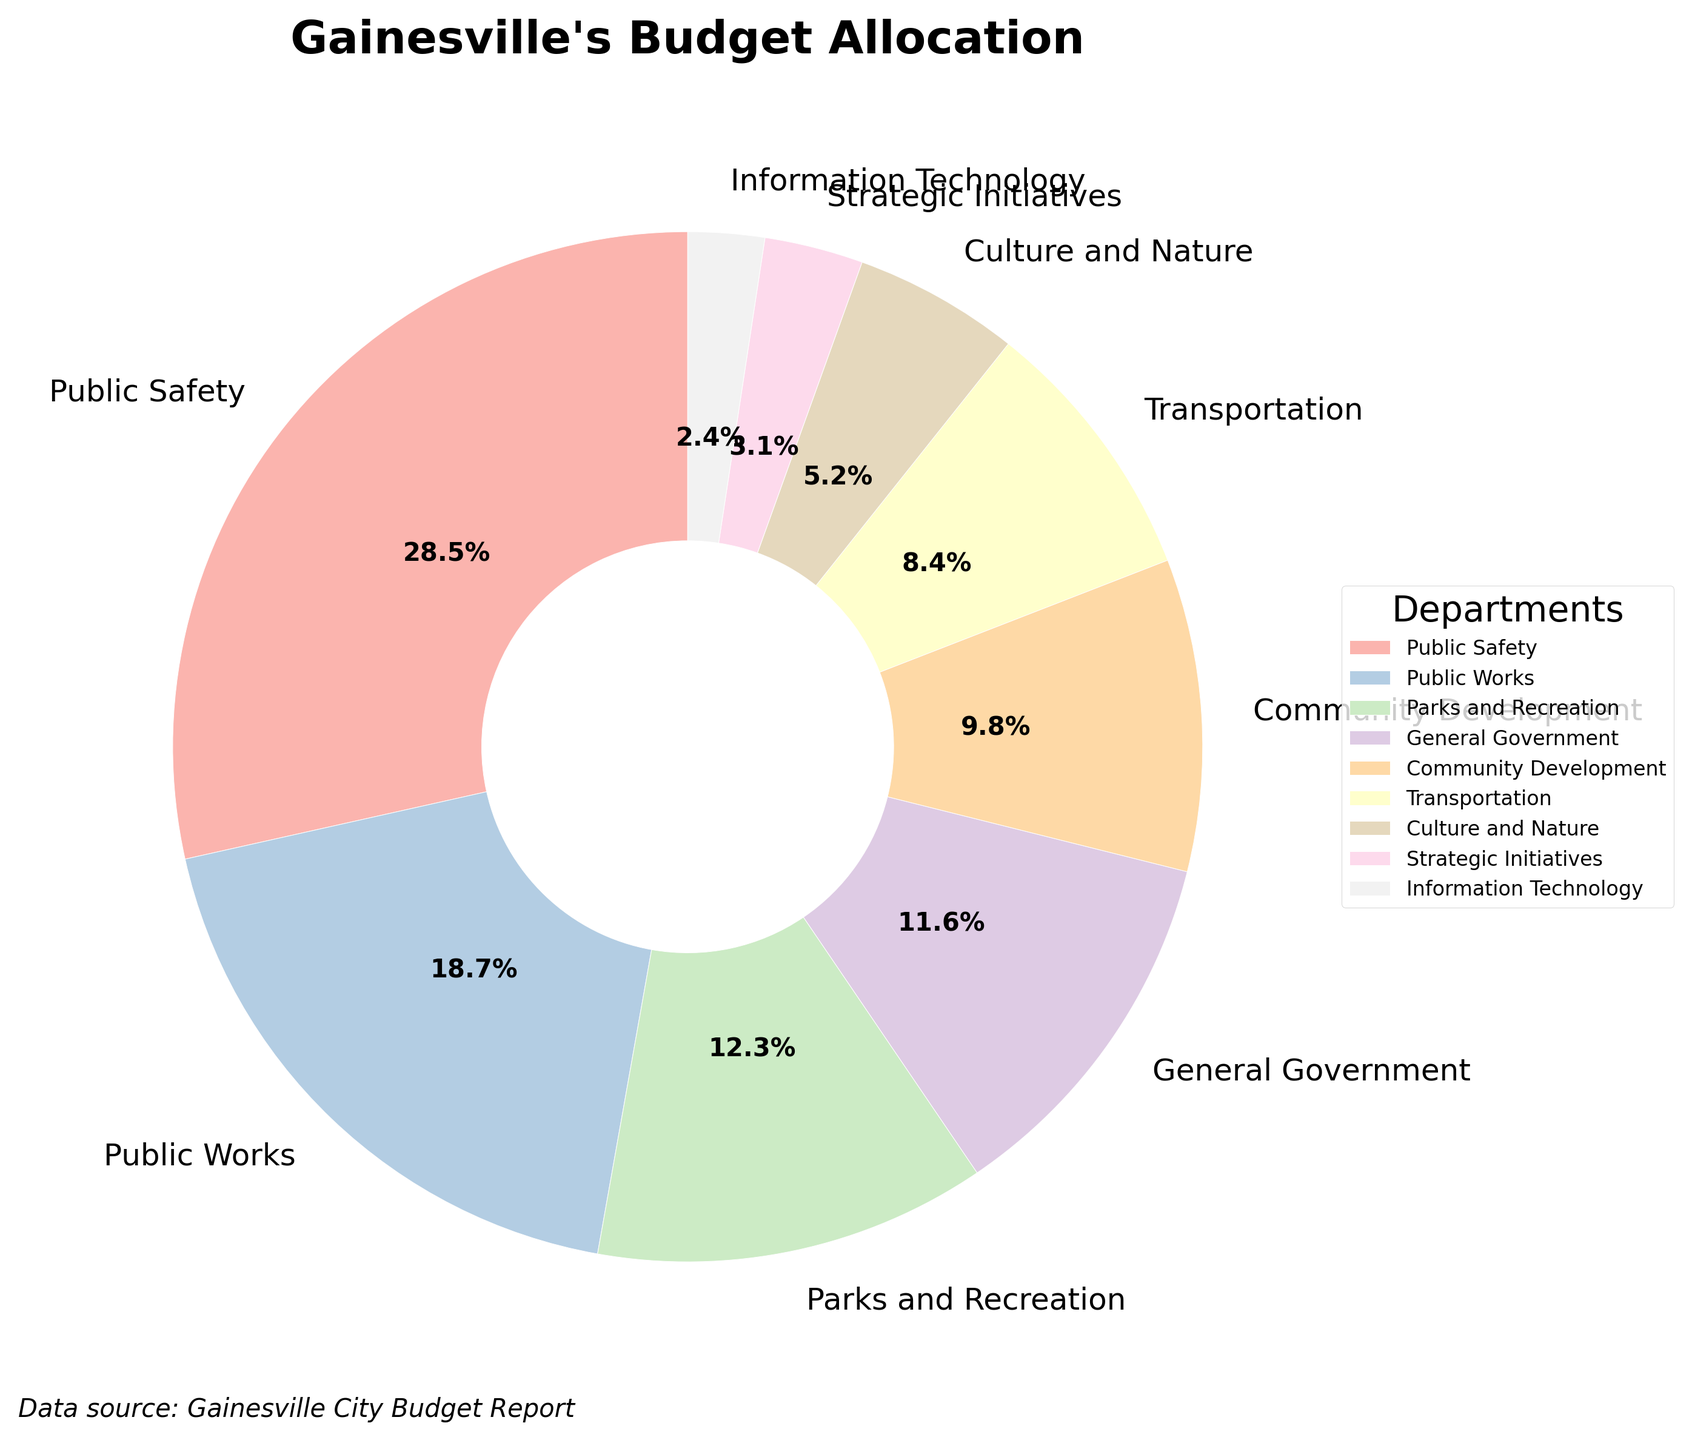What is the total percentage of the budget allocated to Public Safety and Parks and Recreation combined? To find the combined budget percentage for Public Safety and Parks and Recreation, simply add their individual percentages: 28.5% (Public Safety) + 12.3% (Parks and Recreation) = 40.8%.
Answer: 40.8% Which department has the smallest budget allocation? To identify the department with the smallest allocation, look for the department with the lowest percentage on the pie chart. The smallest allocation is to Information Technology with 2.4%.
Answer: Information Technology How much more budget does Public Safety receive compared to Transportation? To find the difference, subtract Transportation's allocation (8.4%) from Public Safety's allocation (28.5%): 28.5% - 8.4% = 20.1%.
Answer: 20.1% Which department receives more budget: Culture and Nature or Community Development? Compare the percentages of the two departments: Culture and Nature receives 5.2%, whereas Community Development receives 9.8%. Community Development has a higher allocation.
Answer: Community Development What is the average budget allocation for Public Works, Parks and Recreation, and General Government? To find the average, first add their percentages: 18.7% (Public Works) + 12.3% (Parks and Recreation) + 11.6% (General Government) = 42.6%. Then, divide by the number of departments (3): 42.6% / 3 = 14.2%.
Answer: 14.2% Which department's wedge on the pie chart is visually the widest? The widest wedge represents the department with the highest budget allocation. Public Safety has the highest allocation at 28.5% and therefore its wedge is the widest.
Answer: Public Safety Are there any departments with an equal budget allocation? Review the percentages for each department. None of the departments have the same allocation; each has a unique percentage.
Answer: No By how much does the allocation for Strategic Initiatives differ from that for Information Technology? To find the difference, subtract Information Technology's allocation (2.4%) from Strategic Initiatives' allocation (3.1%): 3.1% - 2.4% = 0.7%.
Answer: 0.7% If you combine the budgets of the three departments with the smallest allocations, how much would it be in total? Sum the allocations of Strategic Initiatives, Information Technology, and Culture and Nature: 3.1% + 2.4% + 5.2% = 10.7%.
Answer: 10.7% What is the difference between the highest budget allocation and the lowest budget allocation? Subtract the lowest allocation (Information Technology, 2.4%) from the highest allocation (Public Safety, 28.5%): 28.5% - 2.4% = 26.1%.
Answer: 26.1% 